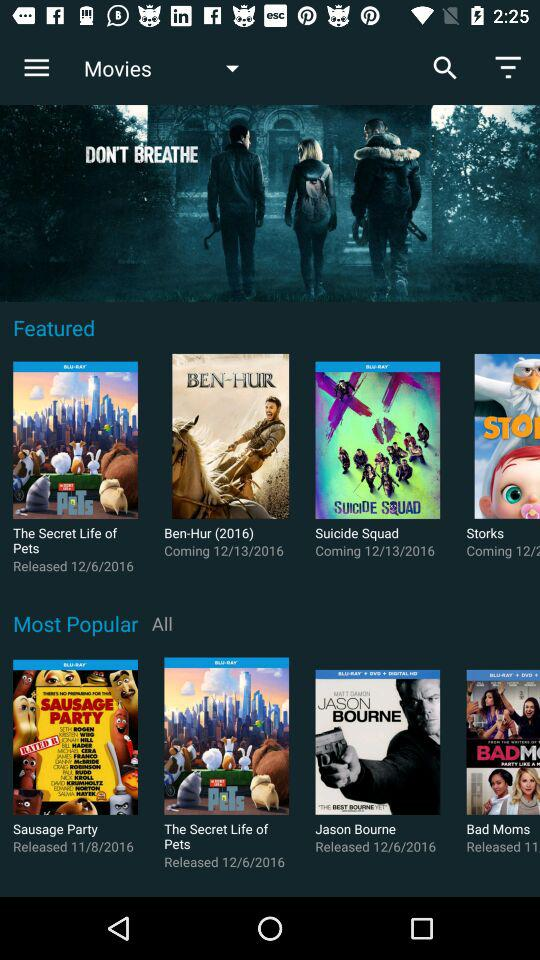Which movie was released on November 8, 2016? The movie "Sausage Party" was released on November 8, 2016. 